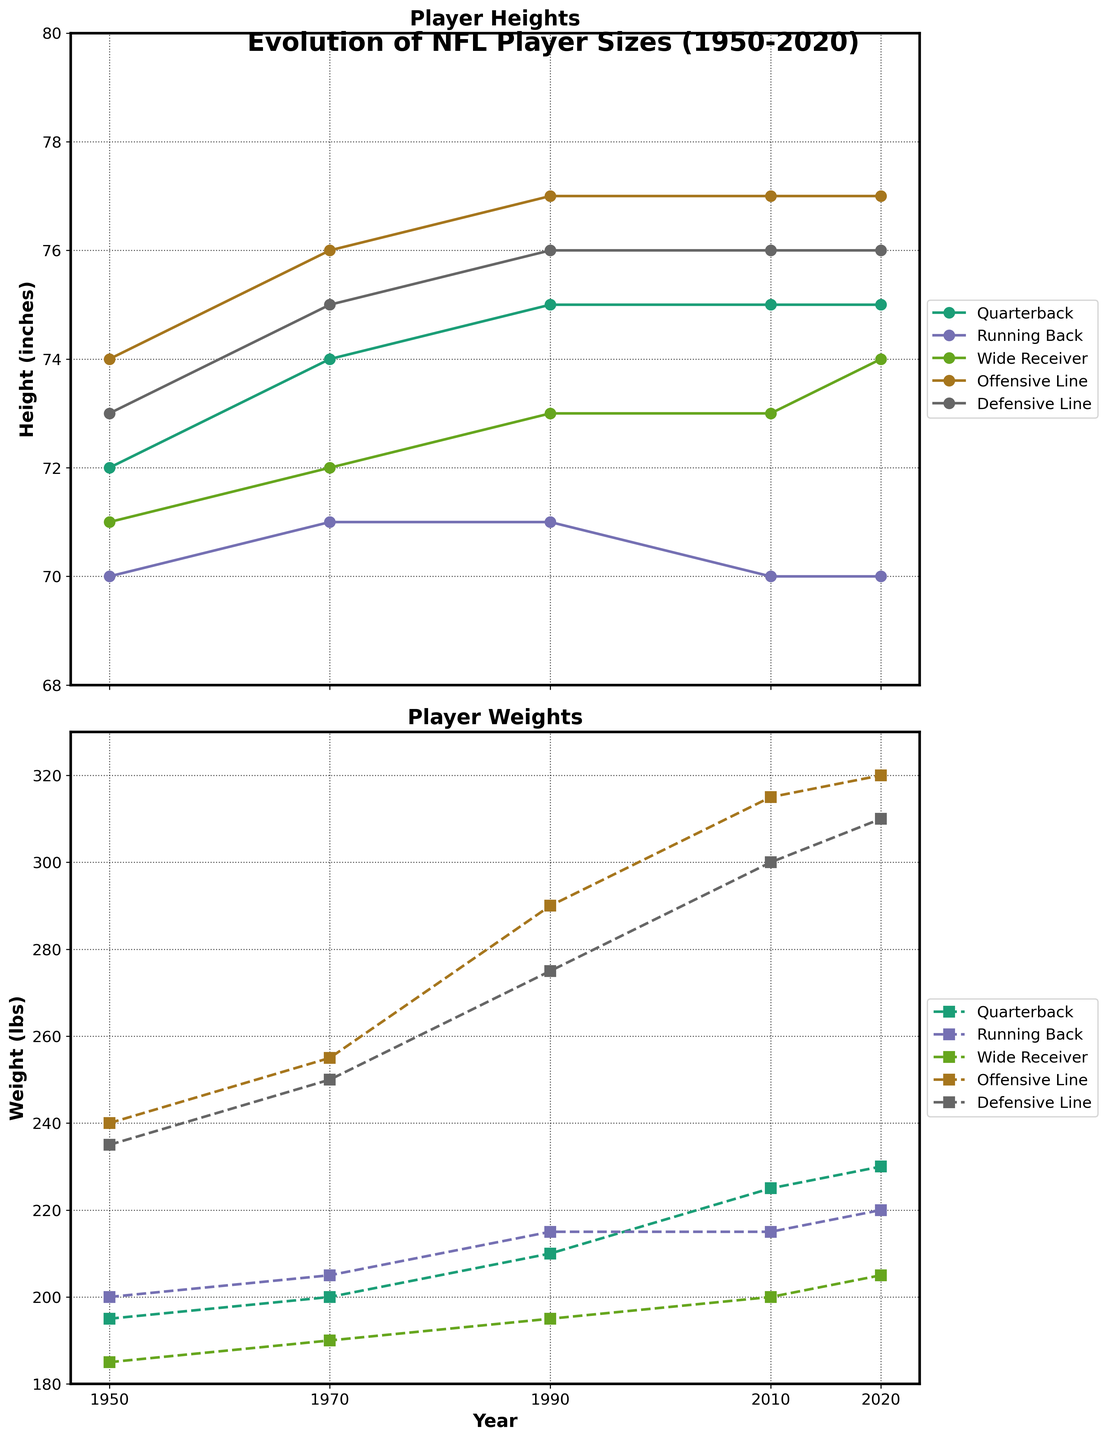What's the title of the figure? The title is usually located at the top of the figure. In this case, it is clearly stated as "Evolution of NFL Player Sizes (1950-2020)."
Answer: Evolution of NFL Player Sizes (1950-2020) What years are represented in the figure? The x-axis of both subplots shows the years included in the data. The years are 1950, 1970, 1990, 2010, and 2020.
Answer: 1950, 1970, 1990, 2010, and 2020 Which position had the tallest average height in 2020? By looking at the top subplot (Player Heights) for the year 2020, the position with the highest point is the Offensive Line.
Answer: Offensive Line How much did the average weight of an Offensive Line player increase from 1950 to 2020? In the bottom subplot (Player Weights), observe the values for Offensive Line in 1950 and 2020. The weight increases from 240 lbs in 1950 to 320 lbs in 2020. The difference is 320 - 240 = 80 lbs.
Answer: 80 lbs Which position showed the smallest increase in average height from 1950 to 2020? Looking at the top subplot (Player Heights) for the values in 1950 and 2020 for each position and calculating the differences, the Running Back had a height from 70 inches in 1950 to 70 inches in 2020, showing no increase.
Answer: Running Back Which position had the greatest increase in average weight between 1950 and 2020? Comparing the differences in the bottom subplot (Player Weights) for each position between 1950 and 2020, the Offensive Line had an increase from 240 lbs to 320 lbs, which is the largest increase.
Answer: Offensive Line How did the height of the average Quarterback change from 1950 to 2020? On the top subplot (Player Heights), trace the Quarterback data points from 1950 to 2020. Heights change from 72 inches in 1950 to 75 inches in 2020.
Answer: Increased by 3 inches What is the typical trend in weight as shown in the figure over the years across all positions? Observing the bottom subplot, it is visible that the weight values for all positions show an increasing trend from 1950 to 2020.
Answer: Increasing How do the height trends of Quarterbacks and Wide Receivers compare from 1950 to 2020? By examining the top subplot, both Quarterback and Wide Receiver lines consistently increase over the years, although Quarterbacks become taller at a slightly faster rate.
Answer: Both increased, but Quarterbacks increased faster Which position had a consistent weight throughout the periods, and what was the trend for other positions? On the bottom subplot (Player Weights), the Running Back has relatively stable weight compared to others, with some increase but not as significant. Other positions show a clear increasing trend.
Answer: Running Back; others increased 